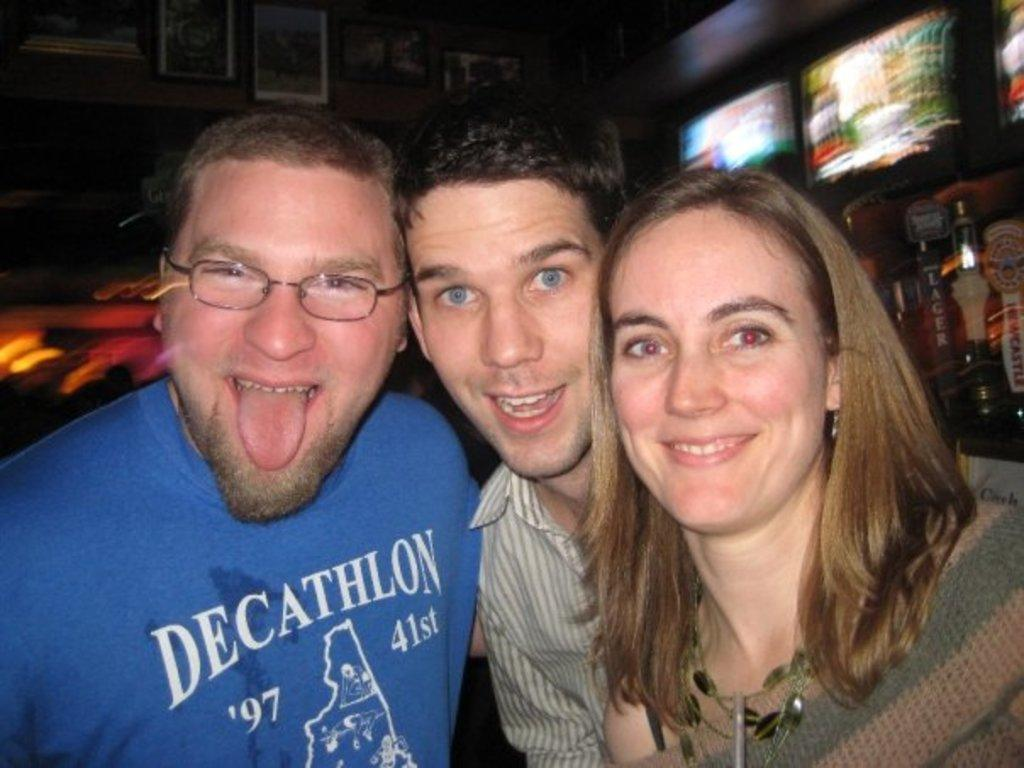What can be observed about the people in the image? There are people standing in the image, and they have smiles on their faces. What is present on the wall in the image? There are photo frames on the wall. What type of electronic device can be seen in the image? There are televisions in the image. Can you see any moons in the image? There are no moons present in the image. What type of berry is being used as a decoration on the board in the image? There is no board or berry present in the image. 